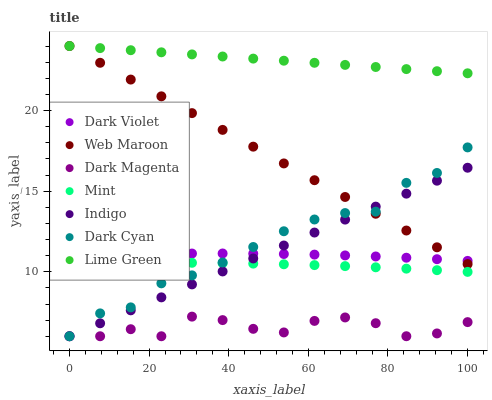Does Dark Magenta have the minimum area under the curve?
Answer yes or no. Yes. Does Lime Green have the maximum area under the curve?
Answer yes or no. Yes. Does Lime Green have the minimum area under the curve?
Answer yes or no. No. Does Dark Magenta have the maximum area under the curve?
Answer yes or no. No. Is Indigo the smoothest?
Answer yes or no. Yes. Is Dark Magenta the roughest?
Answer yes or no. Yes. Is Lime Green the smoothest?
Answer yes or no. No. Is Lime Green the roughest?
Answer yes or no. No. Does Indigo have the lowest value?
Answer yes or no. Yes. Does Lime Green have the lowest value?
Answer yes or no. No. Does Web Maroon have the highest value?
Answer yes or no. Yes. Does Dark Magenta have the highest value?
Answer yes or no. No. Is Mint less than Dark Violet?
Answer yes or no. Yes. Is Lime Green greater than Dark Magenta?
Answer yes or no. Yes. Does Indigo intersect Dark Cyan?
Answer yes or no. Yes. Is Indigo less than Dark Cyan?
Answer yes or no. No. Is Indigo greater than Dark Cyan?
Answer yes or no. No. Does Mint intersect Dark Violet?
Answer yes or no. No. 